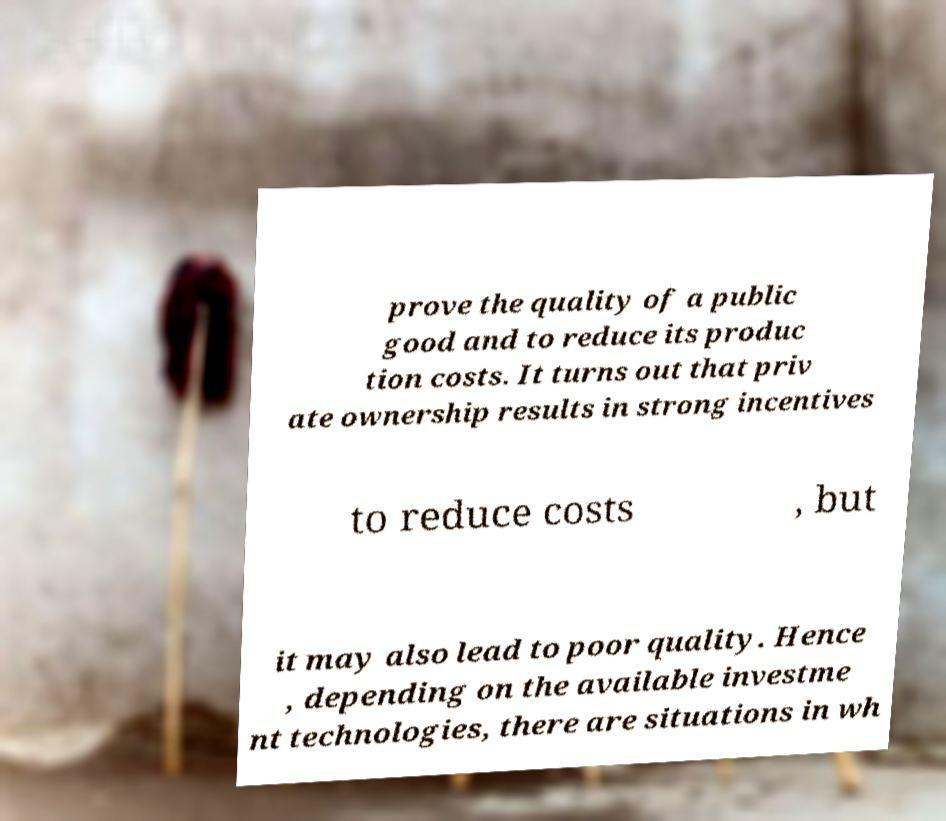I need the written content from this picture converted into text. Can you do that? prove the quality of a public good and to reduce its produc tion costs. It turns out that priv ate ownership results in strong incentives to reduce costs , but it may also lead to poor quality. Hence , depending on the available investme nt technologies, there are situations in wh 